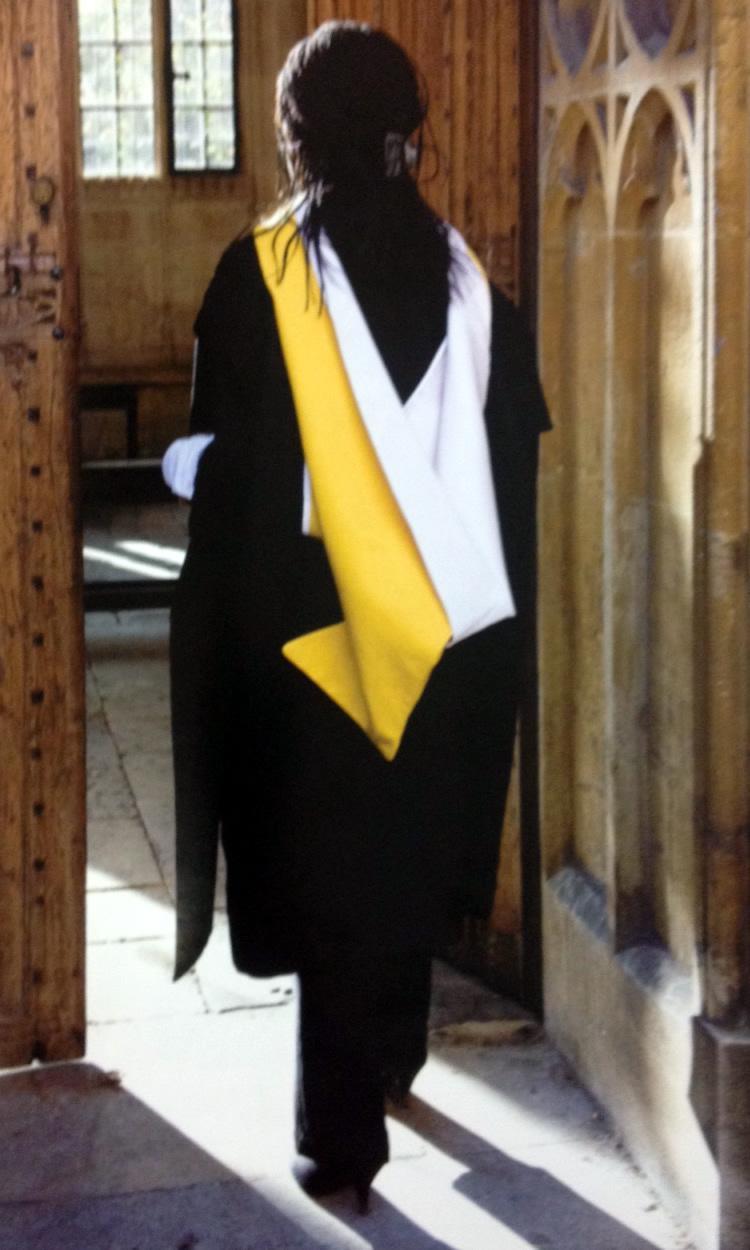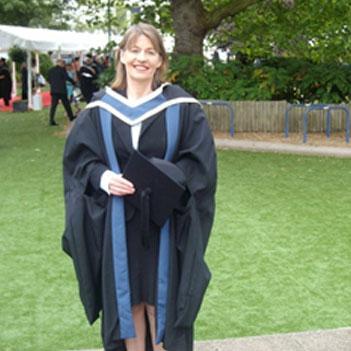The first image is the image on the left, the second image is the image on the right. For the images shown, is this caption "In the right image, the tassle of a graduate's hat is on the left side of the image." true? Answer yes or no. No. The first image is the image on the left, the second image is the image on the right. Considering the images on both sides, is "Each image contains one female graduate, and one image shows a graduate who is not facing forward." valid? Answer yes or no. Yes. 